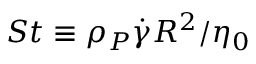Convert formula to latex. <formula><loc_0><loc_0><loc_500><loc_500>S t \equiv \rho _ { P } \dot { \gamma } R ^ { 2 } / \eta _ { 0 }</formula> 